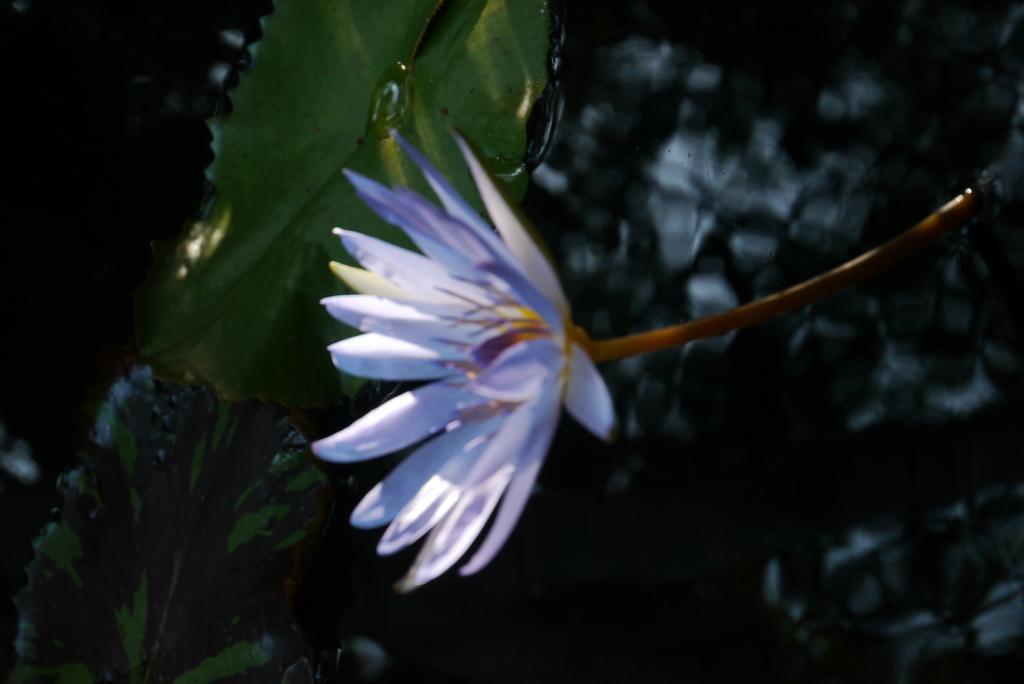Could you give a brief overview of what you see in this image? In the image there is a purple flower in the water with a leaf behind it. 